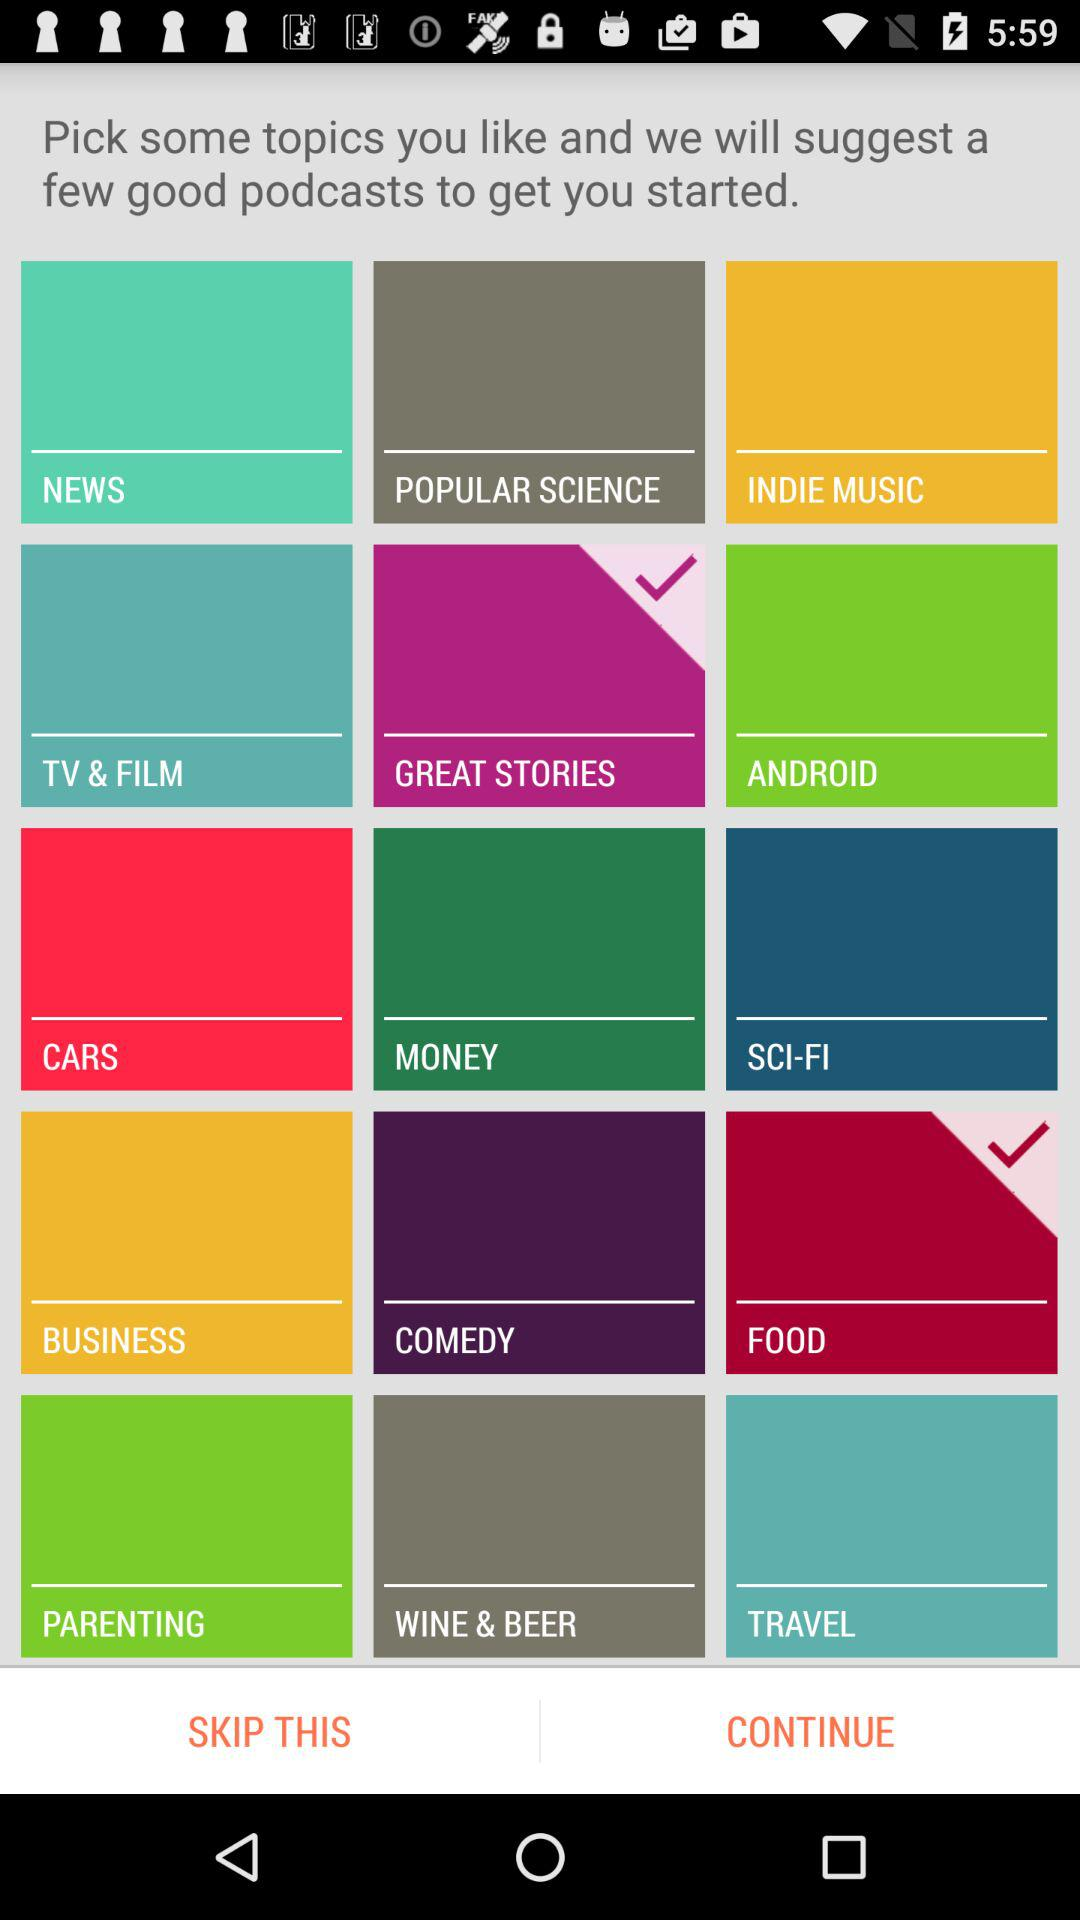Which topics are selected? The selected topics are "GREAT STORIES" and "FOOD". 